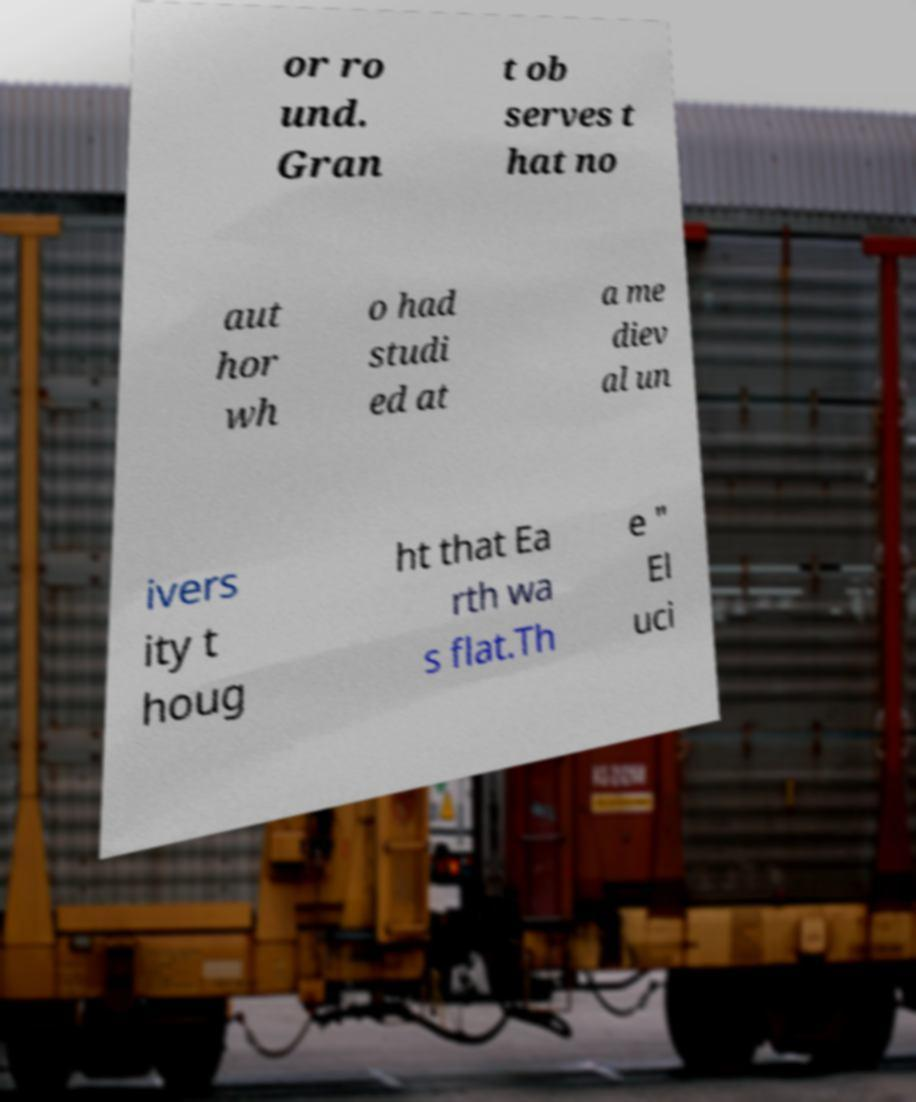There's text embedded in this image that I need extracted. Can you transcribe it verbatim? or ro und. Gran t ob serves t hat no aut hor wh o had studi ed at a me diev al un ivers ity t houg ht that Ea rth wa s flat.Th e " El uci 